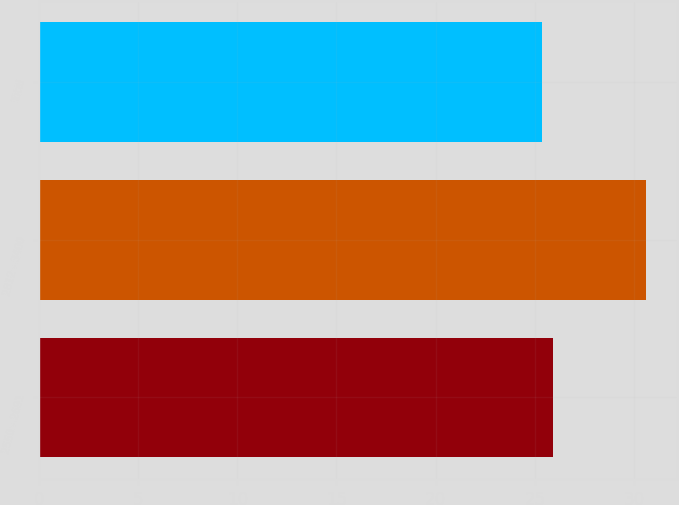Convert chart to OTSL. <chart><loc_0><loc_0><loc_500><loc_500><bar_chart><fcel>2550 - 2691<fcel>2812 - 3400<fcel>Total<nl><fcel>25.89<fcel>30.62<fcel>25.37<nl></chart> 